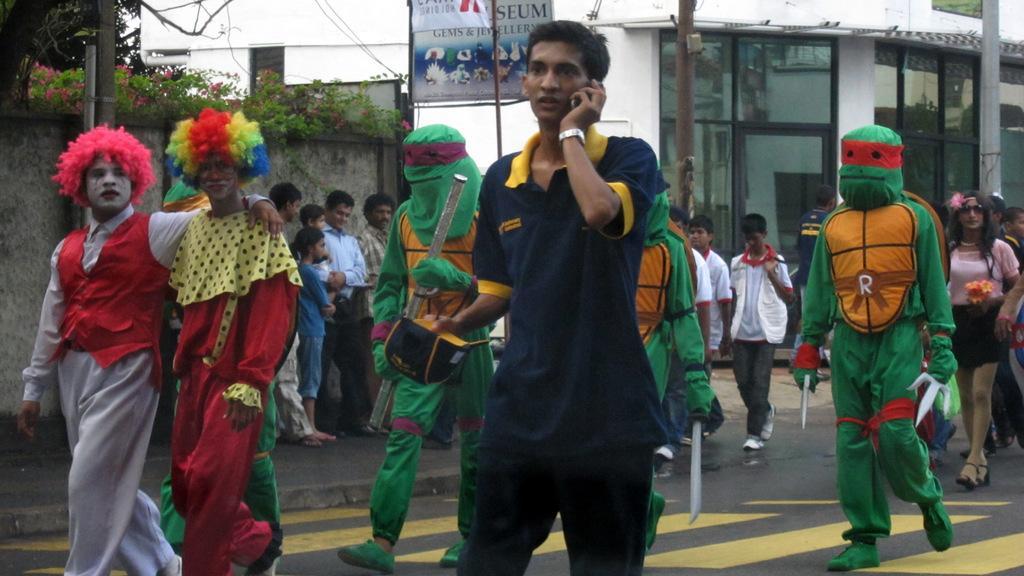Describe this image in one or two sentences. This picture describes about group of people, few are standing, few are walking and few people wore costumes, in the background we can find few buildings, trees, plants and poles. 